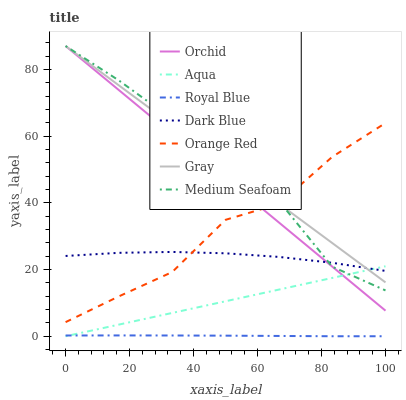Does Royal Blue have the minimum area under the curve?
Answer yes or no. Yes. Does Gray have the maximum area under the curve?
Answer yes or no. Yes. Does Dark Blue have the minimum area under the curve?
Answer yes or no. No. Does Dark Blue have the maximum area under the curve?
Answer yes or no. No. Is Aqua the smoothest?
Answer yes or no. Yes. Is Medium Seafoam the roughest?
Answer yes or no. Yes. Is Dark Blue the smoothest?
Answer yes or no. No. Is Dark Blue the roughest?
Answer yes or no. No. Does Aqua have the lowest value?
Answer yes or no. Yes. Does Dark Blue have the lowest value?
Answer yes or no. No. Does Orchid have the highest value?
Answer yes or no. Yes. Does Dark Blue have the highest value?
Answer yes or no. No. Is Royal Blue less than Orchid?
Answer yes or no. Yes. Is Orchid greater than Royal Blue?
Answer yes or no. Yes. Does Gray intersect Dark Blue?
Answer yes or no. Yes. Is Gray less than Dark Blue?
Answer yes or no. No. Is Gray greater than Dark Blue?
Answer yes or no. No. Does Royal Blue intersect Orchid?
Answer yes or no. No. 